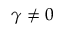Convert formula to latex. <formula><loc_0><loc_0><loc_500><loc_500>\gamma \neq 0</formula> 